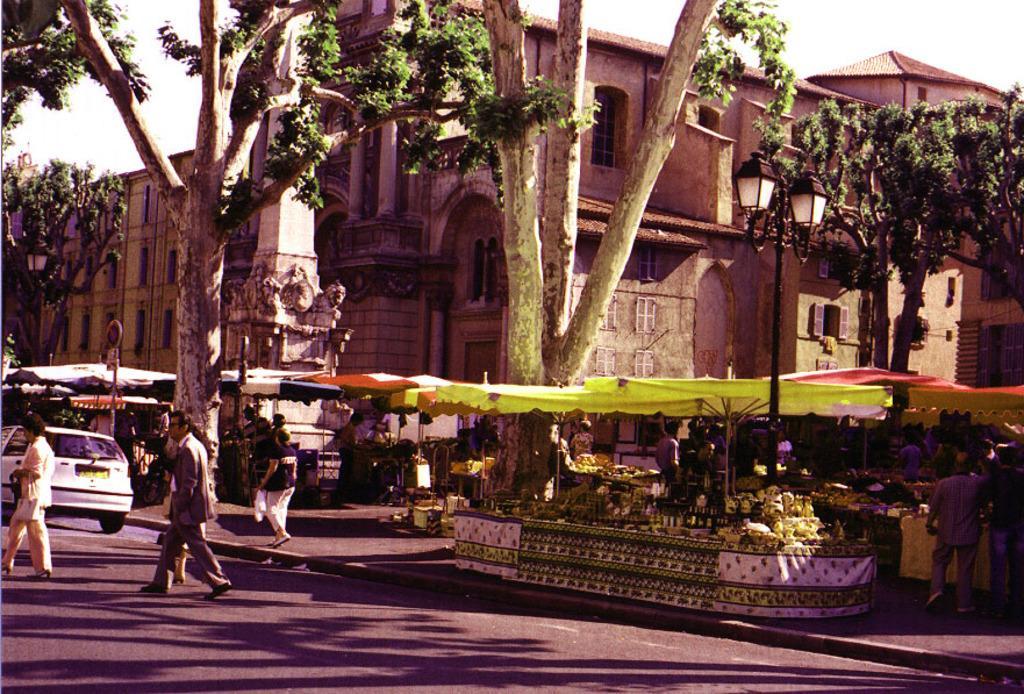Can you describe this image briefly? In this image there are few people are walking on the road and there is a car on the road. At the center of the image there is a building, in front of the building there are trees and stall, in front of the stall there are a few people standing. In the background there is a sky. 